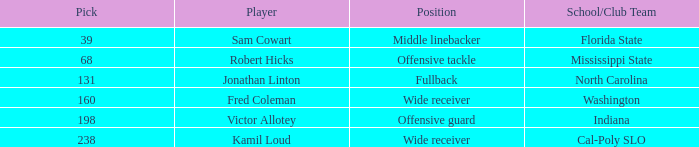Which Round has a School/Club Team of indiana, and a Pick smaller than 198? None. 